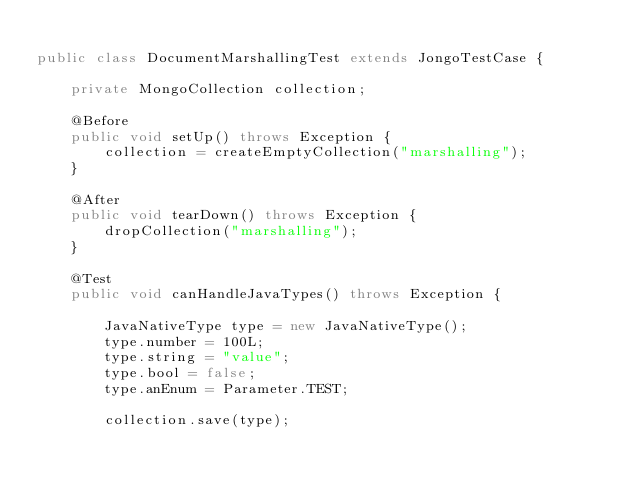<code> <loc_0><loc_0><loc_500><loc_500><_Java_>
public class DocumentMarshallingTest extends JongoTestCase {

    private MongoCollection collection;

    @Before
    public void setUp() throws Exception {
        collection = createEmptyCollection("marshalling");
    }

    @After
    public void tearDown() throws Exception {
        dropCollection("marshalling");
    }

    @Test
    public void canHandleJavaTypes() throws Exception {

        JavaNativeType type = new JavaNativeType();
        type.number = 100L;
        type.string = "value";
        type.bool = false;
        type.anEnum = Parameter.TEST;

        collection.save(type);
</code> 